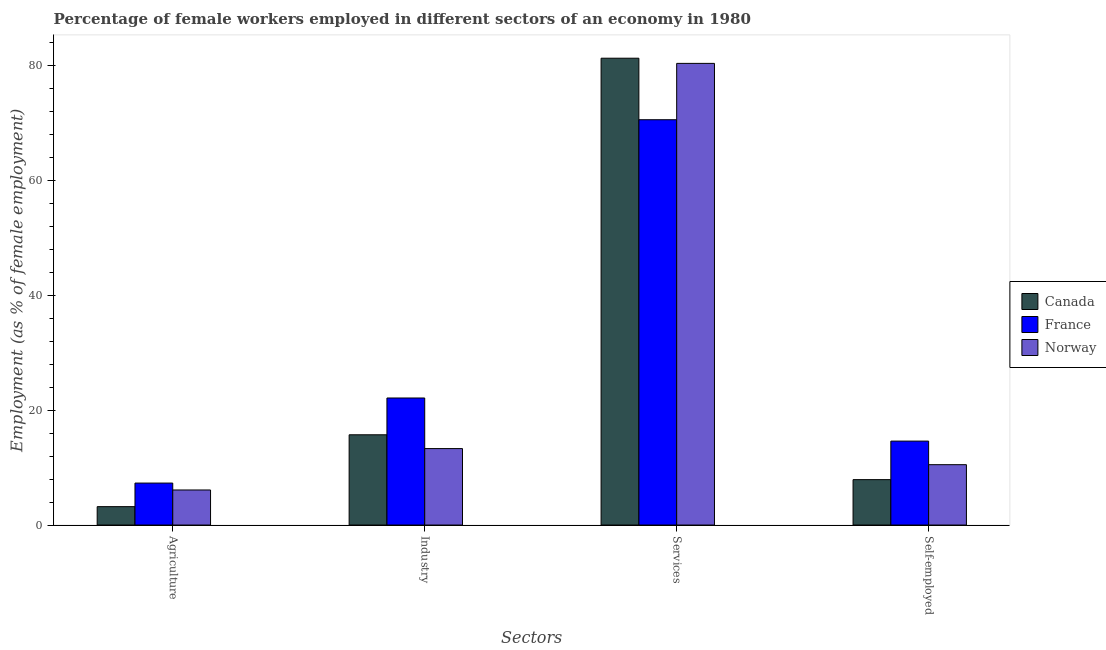How many different coloured bars are there?
Provide a short and direct response. 3. How many groups of bars are there?
Your answer should be very brief. 4. How many bars are there on the 3rd tick from the right?
Keep it short and to the point. 3. What is the label of the 2nd group of bars from the left?
Your answer should be compact. Industry. What is the percentage of female workers in agriculture in France?
Your answer should be very brief. 7.3. Across all countries, what is the maximum percentage of female workers in industry?
Offer a very short reply. 22.1. Across all countries, what is the minimum percentage of female workers in industry?
Keep it short and to the point. 13.3. In which country was the percentage of female workers in services minimum?
Your answer should be very brief. France. What is the total percentage of female workers in industry in the graph?
Your response must be concise. 51.1. What is the difference between the percentage of female workers in agriculture in France and that in Canada?
Offer a very short reply. 4.1. What is the difference between the percentage of female workers in industry in Norway and the percentage of self employed female workers in Canada?
Offer a terse response. 5.4. What is the average percentage of female workers in agriculture per country?
Your answer should be compact. 5.53. What is the difference between the percentage of female workers in agriculture and percentage of female workers in services in Canada?
Your response must be concise. -78. In how many countries, is the percentage of female workers in industry greater than 64 %?
Provide a short and direct response. 0. What is the ratio of the percentage of female workers in agriculture in France to that in Canada?
Your answer should be very brief. 2.28. Is the percentage of female workers in industry in Canada less than that in France?
Keep it short and to the point. Yes. Is the difference between the percentage of female workers in services in Canada and France greater than the difference between the percentage of self employed female workers in Canada and France?
Offer a very short reply. Yes. What is the difference between the highest and the second highest percentage of self employed female workers?
Your answer should be very brief. 4.1. What is the difference between the highest and the lowest percentage of female workers in agriculture?
Your answer should be very brief. 4.1. In how many countries, is the percentage of female workers in industry greater than the average percentage of female workers in industry taken over all countries?
Your response must be concise. 1. Is the sum of the percentage of self employed female workers in Norway and France greater than the maximum percentage of female workers in agriculture across all countries?
Keep it short and to the point. Yes. Is it the case that in every country, the sum of the percentage of female workers in services and percentage of female workers in industry is greater than the sum of percentage of female workers in agriculture and percentage of self employed female workers?
Give a very brief answer. Yes. What does the 3rd bar from the right in Industry represents?
Offer a terse response. Canada. How many bars are there?
Provide a short and direct response. 12. How many countries are there in the graph?
Provide a short and direct response. 3. What is the difference between two consecutive major ticks on the Y-axis?
Give a very brief answer. 20. Are the values on the major ticks of Y-axis written in scientific E-notation?
Keep it short and to the point. No. Where does the legend appear in the graph?
Your response must be concise. Center right. How many legend labels are there?
Your answer should be compact. 3. How are the legend labels stacked?
Make the answer very short. Vertical. What is the title of the graph?
Make the answer very short. Percentage of female workers employed in different sectors of an economy in 1980. Does "Central African Republic" appear as one of the legend labels in the graph?
Your answer should be compact. No. What is the label or title of the X-axis?
Provide a short and direct response. Sectors. What is the label or title of the Y-axis?
Your answer should be compact. Employment (as % of female employment). What is the Employment (as % of female employment) of Canada in Agriculture?
Give a very brief answer. 3.2. What is the Employment (as % of female employment) in France in Agriculture?
Provide a short and direct response. 7.3. What is the Employment (as % of female employment) of Norway in Agriculture?
Offer a very short reply. 6.1. What is the Employment (as % of female employment) in Canada in Industry?
Your answer should be very brief. 15.7. What is the Employment (as % of female employment) in France in Industry?
Your answer should be compact. 22.1. What is the Employment (as % of female employment) of Norway in Industry?
Offer a terse response. 13.3. What is the Employment (as % of female employment) of Canada in Services?
Offer a very short reply. 81.2. What is the Employment (as % of female employment) of France in Services?
Give a very brief answer. 70.5. What is the Employment (as % of female employment) of Norway in Services?
Your response must be concise. 80.3. What is the Employment (as % of female employment) of Canada in Self-employed?
Your response must be concise. 7.9. What is the Employment (as % of female employment) in France in Self-employed?
Make the answer very short. 14.6. What is the Employment (as % of female employment) of Norway in Self-employed?
Offer a very short reply. 10.5. Across all Sectors, what is the maximum Employment (as % of female employment) of Canada?
Give a very brief answer. 81.2. Across all Sectors, what is the maximum Employment (as % of female employment) of France?
Offer a terse response. 70.5. Across all Sectors, what is the maximum Employment (as % of female employment) in Norway?
Your response must be concise. 80.3. Across all Sectors, what is the minimum Employment (as % of female employment) of Canada?
Your response must be concise. 3.2. Across all Sectors, what is the minimum Employment (as % of female employment) of France?
Your response must be concise. 7.3. Across all Sectors, what is the minimum Employment (as % of female employment) of Norway?
Your answer should be very brief. 6.1. What is the total Employment (as % of female employment) of Canada in the graph?
Your response must be concise. 108. What is the total Employment (as % of female employment) of France in the graph?
Your answer should be very brief. 114.5. What is the total Employment (as % of female employment) of Norway in the graph?
Your answer should be compact. 110.2. What is the difference between the Employment (as % of female employment) in Canada in Agriculture and that in Industry?
Make the answer very short. -12.5. What is the difference between the Employment (as % of female employment) in France in Agriculture and that in Industry?
Your answer should be compact. -14.8. What is the difference between the Employment (as % of female employment) in Canada in Agriculture and that in Services?
Provide a short and direct response. -78. What is the difference between the Employment (as % of female employment) in France in Agriculture and that in Services?
Make the answer very short. -63.2. What is the difference between the Employment (as % of female employment) in Norway in Agriculture and that in Services?
Provide a short and direct response. -74.2. What is the difference between the Employment (as % of female employment) in Canada in Agriculture and that in Self-employed?
Give a very brief answer. -4.7. What is the difference between the Employment (as % of female employment) of France in Agriculture and that in Self-employed?
Provide a succinct answer. -7.3. What is the difference between the Employment (as % of female employment) of Norway in Agriculture and that in Self-employed?
Provide a succinct answer. -4.4. What is the difference between the Employment (as % of female employment) of Canada in Industry and that in Services?
Provide a succinct answer. -65.5. What is the difference between the Employment (as % of female employment) in France in Industry and that in Services?
Your response must be concise. -48.4. What is the difference between the Employment (as % of female employment) in Norway in Industry and that in Services?
Make the answer very short. -67. What is the difference between the Employment (as % of female employment) in Canada in Industry and that in Self-employed?
Offer a very short reply. 7.8. What is the difference between the Employment (as % of female employment) in Norway in Industry and that in Self-employed?
Offer a very short reply. 2.8. What is the difference between the Employment (as % of female employment) in Canada in Services and that in Self-employed?
Make the answer very short. 73.3. What is the difference between the Employment (as % of female employment) in France in Services and that in Self-employed?
Provide a succinct answer. 55.9. What is the difference between the Employment (as % of female employment) of Norway in Services and that in Self-employed?
Your answer should be compact. 69.8. What is the difference between the Employment (as % of female employment) in Canada in Agriculture and the Employment (as % of female employment) in France in Industry?
Your answer should be compact. -18.9. What is the difference between the Employment (as % of female employment) of Canada in Agriculture and the Employment (as % of female employment) of France in Services?
Ensure brevity in your answer.  -67.3. What is the difference between the Employment (as % of female employment) in Canada in Agriculture and the Employment (as % of female employment) in Norway in Services?
Your answer should be compact. -77.1. What is the difference between the Employment (as % of female employment) in France in Agriculture and the Employment (as % of female employment) in Norway in Services?
Offer a terse response. -73. What is the difference between the Employment (as % of female employment) in France in Agriculture and the Employment (as % of female employment) in Norway in Self-employed?
Your response must be concise. -3.2. What is the difference between the Employment (as % of female employment) in Canada in Industry and the Employment (as % of female employment) in France in Services?
Ensure brevity in your answer.  -54.8. What is the difference between the Employment (as % of female employment) of Canada in Industry and the Employment (as % of female employment) of Norway in Services?
Ensure brevity in your answer.  -64.6. What is the difference between the Employment (as % of female employment) in France in Industry and the Employment (as % of female employment) in Norway in Services?
Make the answer very short. -58.2. What is the difference between the Employment (as % of female employment) in Canada in Services and the Employment (as % of female employment) in France in Self-employed?
Provide a succinct answer. 66.6. What is the difference between the Employment (as % of female employment) of Canada in Services and the Employment (as % of female employment) of Norway in Self-employed?
Keep it short and to the point. 70.7. What is the average Employment (as % of female employment) of Canada per Sectors?
Offer a very short reply. 27. What is the average Employment (as % of female employment) of France per Sectors?
Offer a terse response. 28.62. What is the average Employment (as % of female employment) in Norway per Sectors?
Keep it short and to the point. 27.55. What is the difference between the Employment (as % of female employment) in France and Employment (as % of female employment) in Norway in Agriculture?
Your response must be concise. 1.2. What is the difference between the Employment (as % of female employment) in France and Employment (as % of female employment) in Norway in Industry?
Your answer should be very brief. 8.8. What is the difference between the Employment (as % of female employment) of Canada and Employment (as % of female employment) of France in Services?
Your answer should be compact. 10.7. What is the difference between the Employment (as % of female employment) in Canada and Employment (as % of female employment) in France in Self-employed?
Ensure brevity in your answer.  -6.7. What is the difference between the Employment (as % of female employment) in France and Employment (as % of female employment) in Norway in Self-employed?
Keep it short and to the point. 4.1. What is the ratio of the Employment (as % of female employment) of Canada in Agriculture to that in Industry?
Offer a very short reply. 0.2. What is the ratio of the Employment (as % of female employment) in France in Agriculture to that in Industry?
Offer a very short reply. 0.33. What is the ratio of the Employment (as % of female employment) in Norway in Agriculture to that in Industry?
Your answer should be very brief. 0.46. What is the ratio of the Employment (as % of female employment) of Canada in Agriculture to that in Services?
Provide a short and direct response. 0.04. What is the ratio of the Employment (as % of female employment) in France in Agriculture to that in Services?
Offer a terse response. 0.1. What is the ratio of the Employment (as % of female employment) of Norway in Agriculture to that in Services?
Provide a succinct answer. 0.08. What is the ratio of the Employment (as % of female employment) of Canada in Agriculture to that in Self-employed?
Offer a very short reply. 0.41. What is the ratio of the Employment (as % of female employment) of France in Agriculture to that in Self-employed?
Your answer should be very brief. 0.5. What is the ratio of the Employment (as % of female employment) in Norway in Agriculture to that in Self-employed?
Provide a succinct answer. 0.58. What is the ratio of the Employment (as % of female employment) of Canada in Industry to that in Services?
Offer a terse response. 0.19. What is the ratio of the Employment (as % of female employment) in France in Industry to that in Services?
Make the answer very short. 0.31. What is the ratio of the Employment (as % of female employment) of Norway in Industry to that in Services?
Make the answer very short. 0.17. What is the ratio of the Employment (as % of female employment) in Canada in Industry to that in Self-employed?
Give a very brief answer. 1.99. What is the ratio of the Employment (as % of female employment) in France in Industry to that in Self-employed?
Give a very brief answer. 1.51. What is the ratio of the Employment (as % of female employment) in Norway in Industry to that in Self-employed?
Ensure brevity in your answer.  1.27. What is the ratio of the Employment (as % of female employment) in Canada in Services to that in Self-employed?
Your answer should be very brief. 10.28. What is the ratio of the Employment (as % of female employment) of France in Services to that in Self-employed?
Provide a short and direct response. 4.83. What is the ratio of the Employment (as % of female employment) in Norway in Services to that in Self-employed?
Give a very brief answer. 7.65. What is the difference between the highest and the second highest Employment (as % of female employment) in Canada?
Offer a very short reply. 65.5. What is the difference between the highest and the second highest Employment (as % of female employment) of France?
Provide a short and direct response. 48.4. What is the difference between the highest and the second highest Employment (as % of female employment) of Norway?
Give a very brief answer. 67. What is the difference between the highest and the lowest Employment (as % of female employment) in France?
Provide a succinct answer. 63.2. What is the difference between the highest and the lowest Employment (as % of female employment) in Norway?
Give a very brief answer. 74.2. 